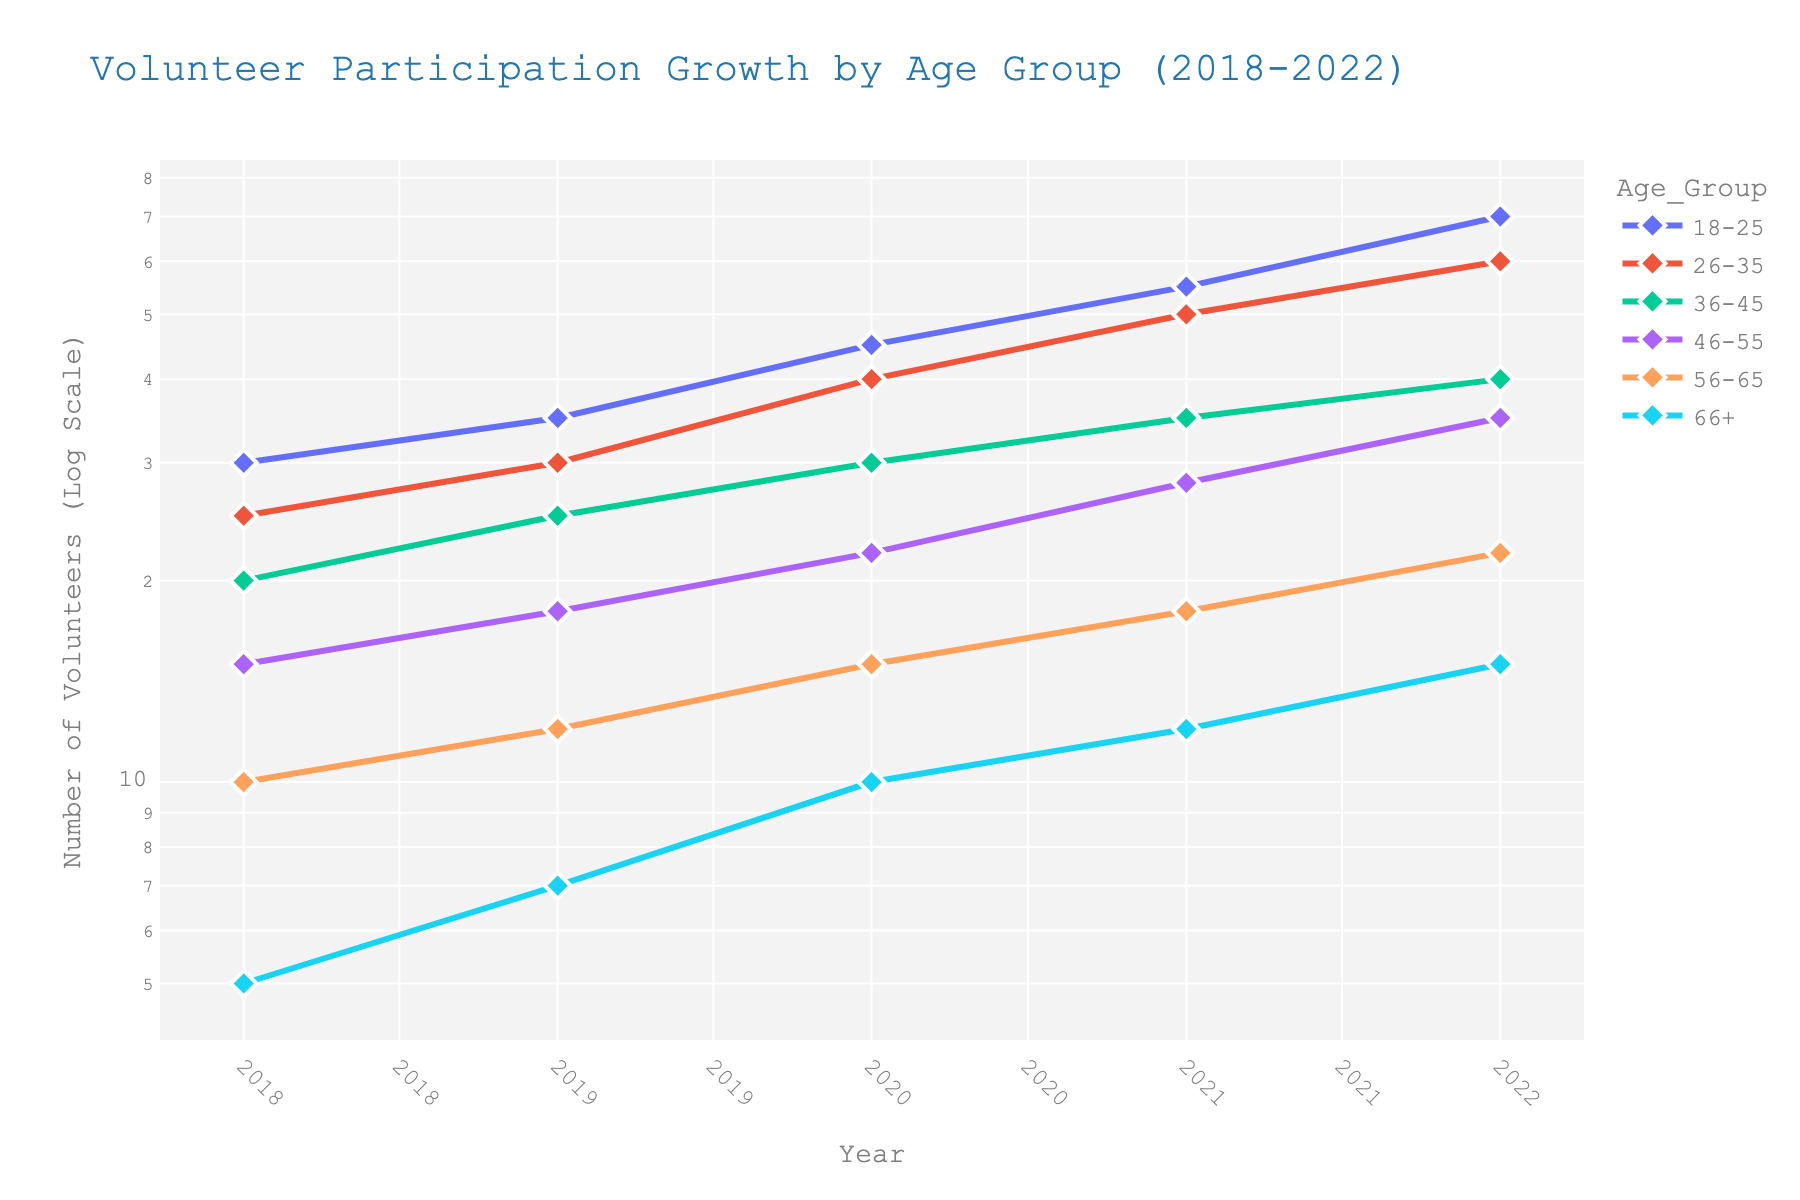What is the title of the figure? The title is displayed at the top of the figure, indicating what the plot represents.
Answer: Volunteer Participation Growth by Age Group (2018-2022) What age group had the highest number of volunteers in 2022? To find this, look at the endpoints (2022) of each line in the plot and compare the values. The highest point corresponds to the age group 18-25.
Answer: 18-25 Which age group showed the least growth in volunteer count from 2018 to 2022? Calculate the difference in volunteer counts between 2018 and 2022 for each age group. The age group with the smallest difference is 66+.
Answer: 66+ What is the volunteer count for the 46-55 age group in 2020? Look along the 2020 vertical line until you find the data point for the 46-55 age group line. Read the value off the y-axis.
Answer: 22 Which age group had the most consistent growth pattern over the years? Consistent growth is represented by a line that progresses smoothly upwards without big jumps. The 36-45 age group's line shows consistent growth.
Answer: 36-45 What is the average volunteer count for the 26-35 age group between 2018 and 2022? Sum the volunteer counts for the 26-35 age group across the years (25+30+40+50+60) and divide by the number of years (5).
Answer: 41 Did any age group experience a decline in volunteer numbers in any year? Check if any lines dip downward at any point. None of the lines show a declining trend.
Answer: No By how much did volunteer numbers for the 56-65 age group increase between 2018 and 2022? Subtract the 2018 volunteer count from the 2022 count for the 56-65 age group (22 - 10).
Answer: 12 How does the growth trend of the 18-25 age group compare to the 66+ age group? Analyze the slopes of the lines; the 18-25 age group shows a much steeper ascent compared to the gentler slope of the 66+ age group, indicating faster growth.
Answer: Faster Which age group crossed the 50 volunteer mark first? Look at the points where each line first crosses the y-value of 50. The 18-25 age group crosses it before any other age group.
Answer: 18-25 